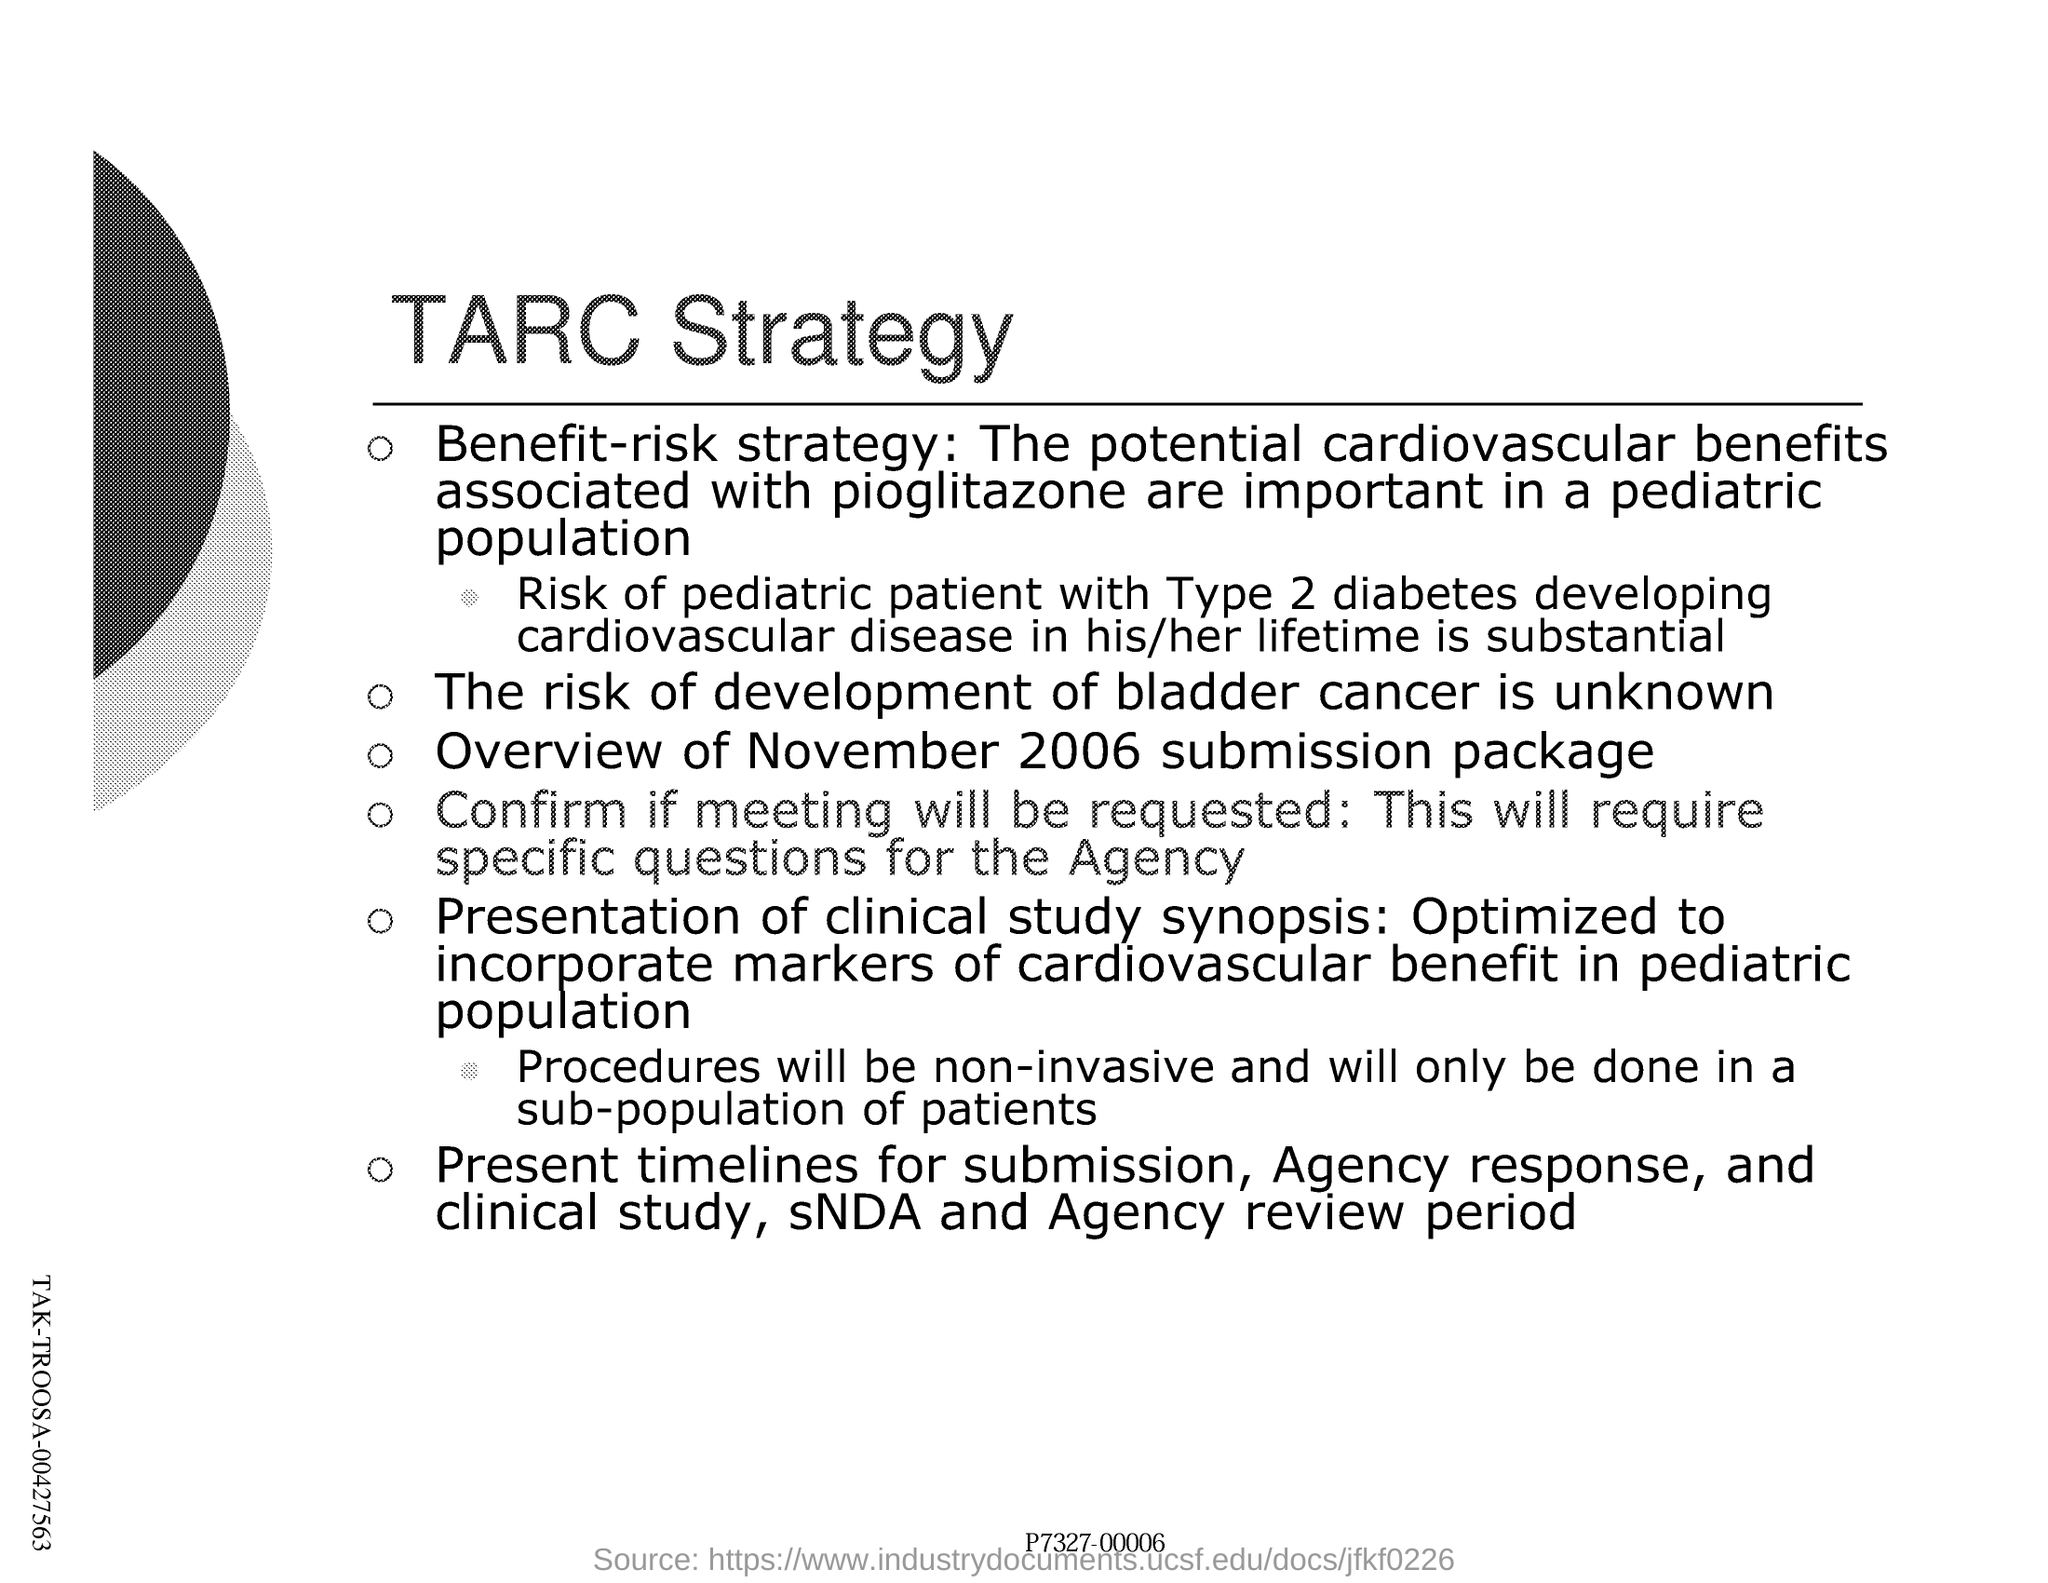Specify some key components in this picture. The document in question is titled "TARC Strategy. 